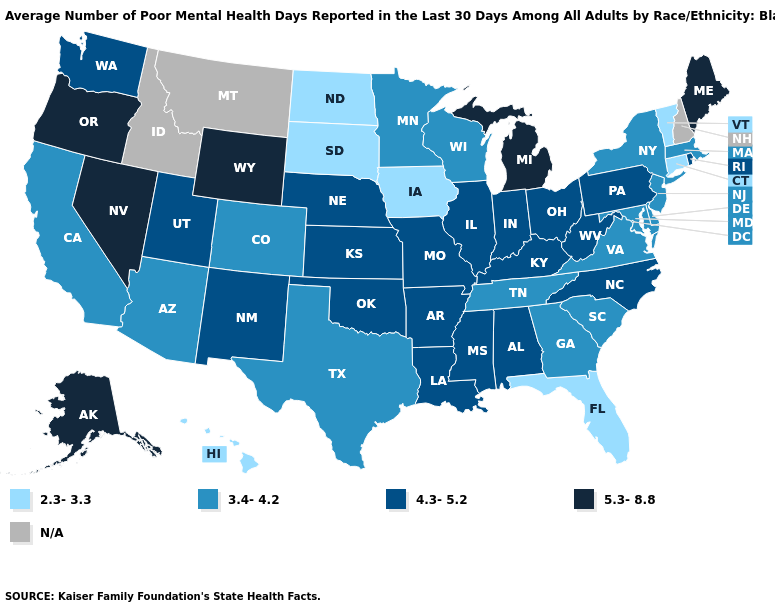Name the states that have a value in the range 5.3-8.8?
Keep it brief. Alaska, Maine, Michigan, Nevada, Oregon, Wyoming. Does Colorado have the highest value in the USA?
Short answer required. No. What is the lowest value in the South?
Keep it brief. 2.3-3.3. Name the states that have a value in the range 3.4-4.2?
Concise answer only. Arizona, California, Colorado, Delaware, Georgia, Maryland, Massachusetts, Minnesota, New Jersey, New York, South Carolina, Tennessee, Texas, Virginia, Wisconsin. How many symbols are there in the legend?
Write a very short answer. 5. Name the states that have a value in the range 5.3-8.8?
Answer briefly. Alaska, Maine, Michigan, Nevada, Oregon, Wyoming. What is the highest value in states that border South Carolina?
Write a very short answer. 4.3-5.2. Among the states that border Arkansas , which have the lowest value?
Be succinct. Tennessee, Texas. Does Utah have the highest value in the West?
Quick response, please. No. Among the states that border Oklahoma , which have the highest value?
Keep it brief. Arkansas, Kansas, Missouri, New Mexico. What is the value of North Carolina?
Write a very short answer. 4.3-5.2. Is the legend a continuous bar?
Be succinct. No. What is the highest value in the South ?
Keep it brief. 4.3-5.2. 